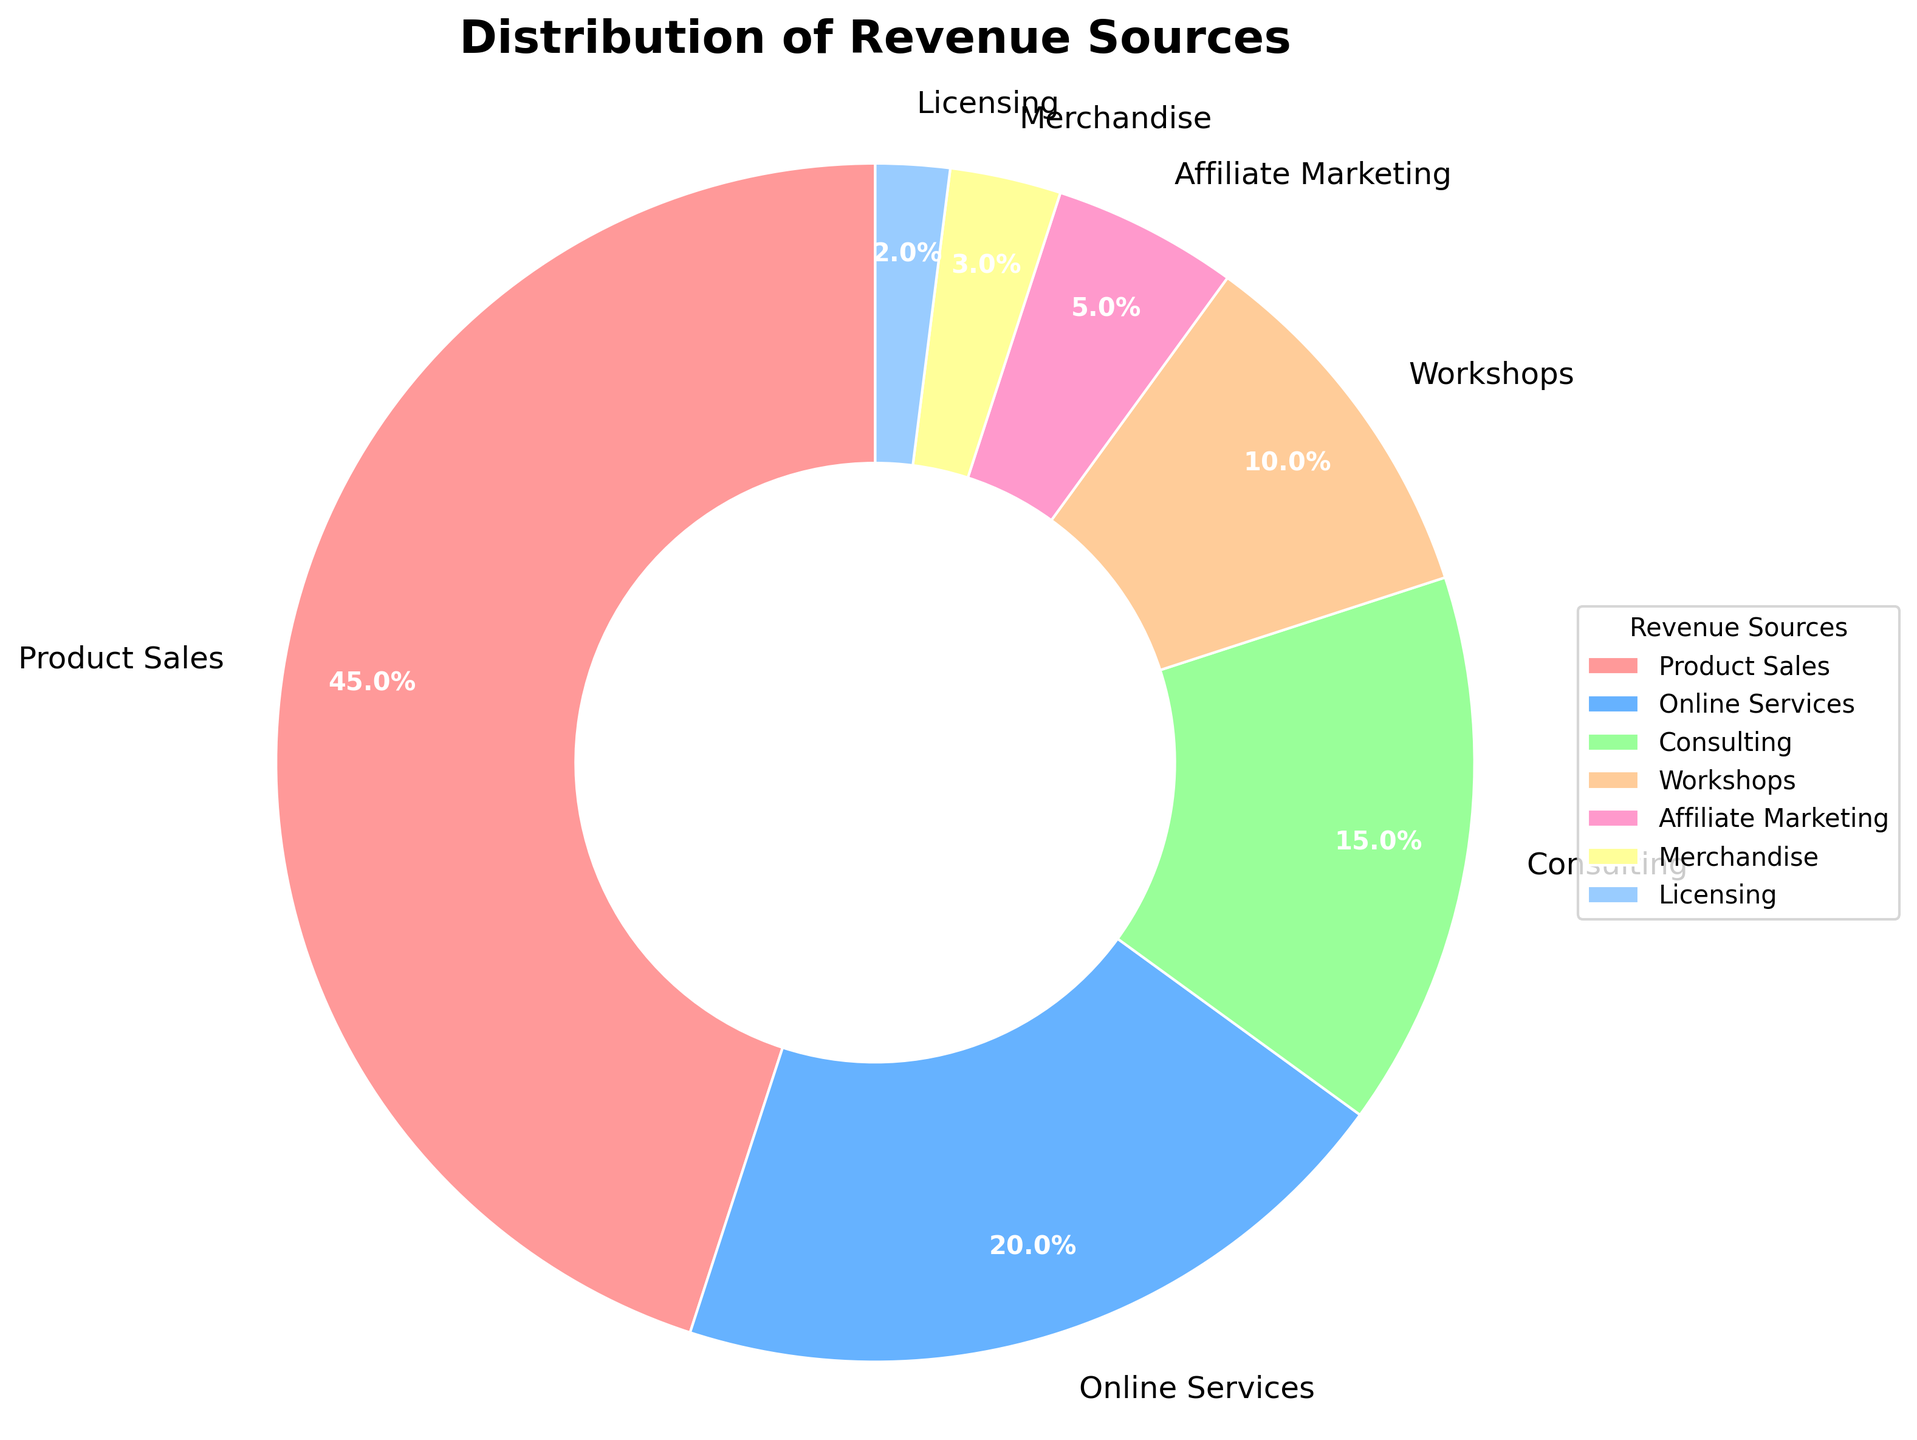Which revenue source contributes the most to the overall revenue? The figure shows that Product Sales has the largest slice of the pie chart, indicating it contributes the most.
Answer: Product Sales What is the combined percentage of revenue from Consulting and Workshops? The percentage for Consulting is 15% and for Workshops is 10%. Adding them together: 15% + 10% = 25%.
Answer: 25% Which revenue source contributes the least to the overall revenue? The figure shows that Licensing has the smallest slice of the pie chart, indicating it contributes the least.
Answer: Licensing How much more does Product Sales contribute compared to Online Services? The contribution of Product Sales is 45% and Online Services is 20%. The difference is 45% - 20% = 25%.
Answer: 25% If Merchandise and Licensing are combined, what is their total contribution to the revenue? The contribution of Merchandise is 3% and Licensing is 2%. Adding them together: 3% + 2% = 5%.
Answer: 5% What are the top three largest revenue sources? By visually comparing the sizes of the slices, the top three largest revenue sources are Product Sales, Online Services, and Consulting.
Answer: Product Sales, Online Services, Consulting What is the difference in percentage between the highest and lowest revenue sources? The highest revenue source is Product Sales at 45%, and the lowest is Licensing at 2%. The difference is 45% - 2% = 43%.
Answer: 43% Are Workshops contributing more to the revenue than Affiliate Marketing? By comparing the sizes of the slices, the slice for Workshops (10%) is larger than that for Affiliate Marketing (5%).
Answer: Yes What is the total contribution of revenue from sources other than Product Sales? The total contribution from sources other than Product Sales can be found by subtracting the Product Sales percentage from 100%. This is 100% - 45% = 55%.
Answer: 55% What is the average contribution of all revenue sources except Product Sales? Excluding Product Sales which is 45%, the remaining percentages are: 20%, 15%, 10%, 5%, 3%, 2%. The sum is 55% and there are 6 sources, so the average is 55% / 6 ≈ 9.17%.
Answer: 9.17% 